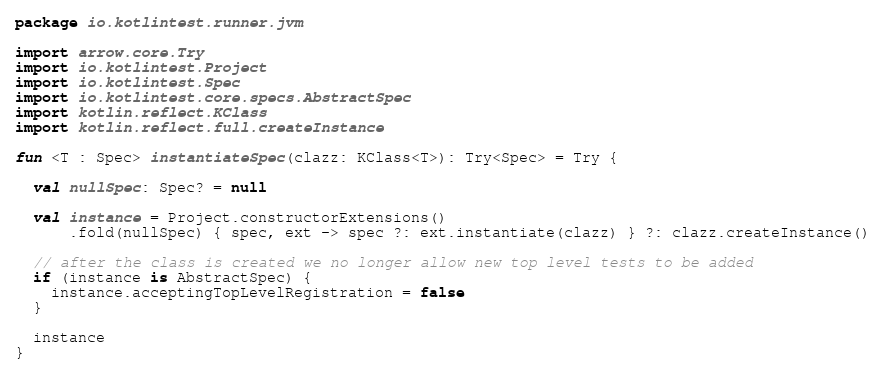<code> <loc_0><loc_0><loc_500><loc_500><_Kotlin_>package io.kotlintest.runner.jvm

import arrow.core.Try
import io.kotlintest.Project
import io.kotlintest.Spec
import io.kotlintest.core.specs.AbstractSpec
import kotlin.reflect.KClass
import kotlin.reflect.full.createInstance

fun <T : Spec> instantiateSpec(clazz: KClass<T>): Try<Spec> = Try {

  val nullSpec: Spec? = null

  val instance = Project.constructorExtensions()
      .fold(nullSpec) { spec, ext -> spec ?: ext.instantiate(clazz) } ?: clazz.createInstance()

  // after the class is created we no longer allow new top level tests to be added
  if (instance is AbstractSpec) {
    instance.acceptingTopLevelRegistration = false
  }

  instance
}
</code> 